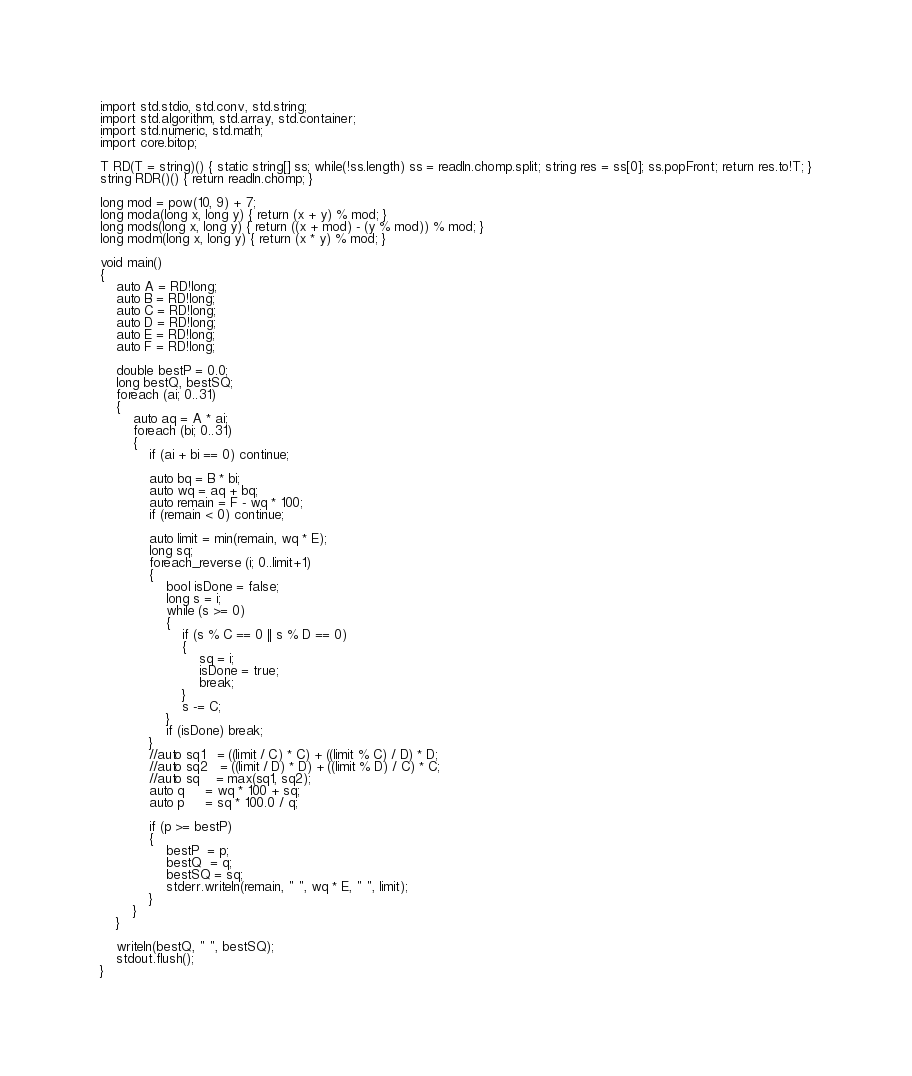<code> <loc_0><loc_0><loc_500><loc_500><_D_>import std.stdio, std.conv, std.string;
import std.algorithm, std.array, std.container;
import std.numeric, std.math;
import core.bitop;

T RD(T = string)() { static string[] ss; while(!ss.length) ss = readln.chomp.split; string res = ss[0]; ss.popFront; return res.to!T; }
string RDR()() { return readln.chomp; }

long mod = pow(10, 9) + 7;
long moda(long x, long y) { return (x + y) % mod; }
long mods(long x, long y) { return ((x + mod) - (y % mod)) % mod; }
long modm(long x, long y) { return (x * y) % mod; }

void main()
{
	auto A = RD!long;
	auto B = RD!long;
	auto C = RD!long;
	auto D = RD!long;
	auto E = RD!long;
	auto F = RD!long;

	double bestP = 0.0;
	long bestQ, bestSQ;
	foreach (ai; 0..31)
	{
		auto aq = A * ai;
		foreach (bi; 0..31)
		{
			if (ai + bi == 0) continue;

			auto bq = B * bi;
			auto wq = aq + bq;
			auto remain = F - wq * 100;
			if (remain < 0) continue;

			auto limit = min(remain, wq * E);
			long sq;
			foreach_reverse (i; 0..limit+1)
			{
				bool isDone = false;
				long s = i;
				while (s >= 0)
				{
					if (s % C == 0 || s % D == 0)
					{
						sq = i;
						isDone = true;
						break;
					}
					s -= C;
				}
				if (isDone) break;
			}
			//auto sq1   = ((limit / C) * C) + ((limit % C) / D) * D;
			//auto sq2   = ((limit / D) * D) + ((limit % D) / C) * C;
			//auto sq    = max(sq1, sq2);
			auto q     = wq * 100 + sq;
			auto p     = sq * 100.0 / q;

			if (p >= bestP)
			{
				bestP  = p;
				bestQ  = q;
				bestSQ = sq;
				stderr.writeln(remain, " ", wq * E, " ", limit);
			}
		}
	}
	
	writeln(bestQ, " ", bestSQ);
	stdout.flush();
}</code> 